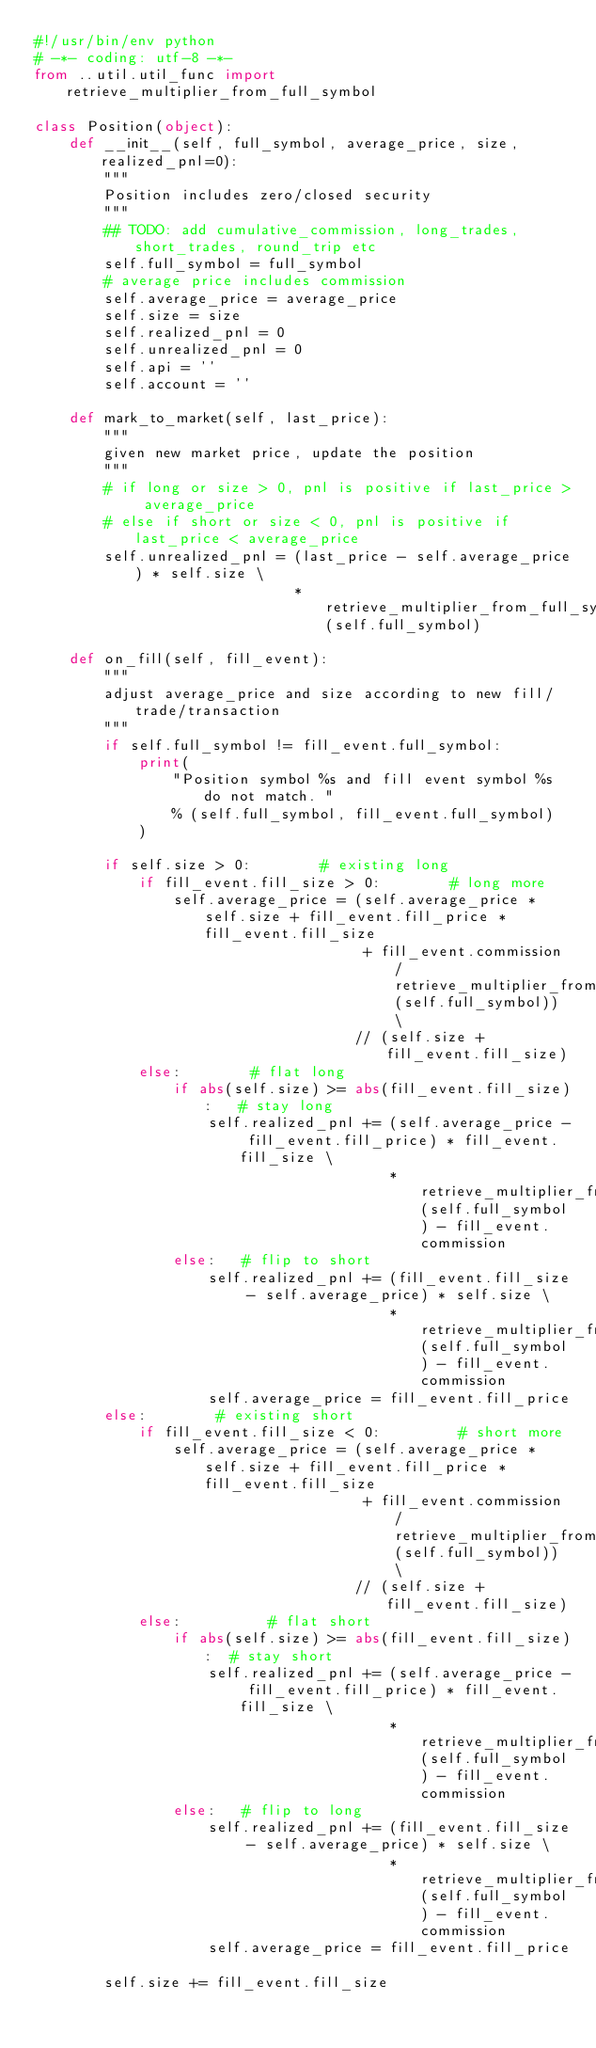Convert code to text. <code><loc_0><loc_0><loc_500><loc_500><_Python_>#!/usr/bin/env python
# -*- coding: utf-8 -*-
from ..util.util_func import retrieve_multiplier_from_full_symbol

class Position(object):
    def __init__(self, full_symbol, average_price, size, realized_pnl=0):
        """
        Position includes zero/closed security
        """
        ## TODO: add cumulative_commission, long_trades, short_trades, round_trip etc
        self.full_symbol = full_symbol
        # average price includes commission
        self.average_price = average_price
        self.size = size
        self.realized_pnl = 0
        self.unrealized_pnl = 0
        self.api = ''
        self.account = ''

    def mark_to_market(self, last_price):
        """
        given new market price, update the position
        """
        # if long or size > 0, pnl is positive if last_price > average_price
        # else if short or size < 0, pnl is positive if last_price < average_price
        self.unrealized_pnl = (last_price - self.average_price) * self.size \
                              * retrieve_multiplier_from_full_symbol(self.full_symbol)

    def on_fill(self, fill_event):
        """
        adjust average_price and size according to new fill/trade/transaction
        """
        if self.full_symbol != fill_event.full_symbol:
            print(
                "Position symbol %s and fill event symbol %s do not match. "
                % (self.full_symbol, fill_event.full_symbol)
            )

        if self.size > 0:        # existing long
            if fill_event.fill_size > 0:        # long more
                self.average_price = (self.average_price * self.size + fill_event.fill_price * fill_event.fill_size
                                      + fill_event.commission / retrieve_multiplier_from_full_symbol(self.full_symbol)) \
                                     // (self.size + fill_event.fill_size)
            else:        # flat long
                if abs(self.size) >= abs(fill_event.fill_size):   # stay long
                    self.realized_pnl += (self.average_price - fill_event.fill_price) * fill_event.fill_size \
                                         * retrieve_multiplier_from_full_symbol(self.full_symbol) - fill_event.commission
                else:   # flip to short
                    self.realized_pnl += (fill_event.fill_size - self.average_price) * self.size \
                                         * retrieve_multiplier_from_full_symbol(self.full_symbol) - fill_event.commission
                    self.average_price = fill_event.fill_price
        else:        # existing short
            if fill_event.fill_size < 0:         # short more
                self.average_price = (self.average_price * self.size + fill_event.fill_price * fill_event.fill_size
                                      + fill_event.commission / retrieve_multiplier_from_full_symbol(self.full_symbol)) \
                                     // (self.size + fill_event.fill_size)
            else:          # flat short
                if abs(self.size) >= abs(fill_event.fill_size):  # stay short
                    self.realized_pnl += (self.average_price - fill_event.fill_price) * fill_event.fill_size \
                                         * retrieve_multiplier_from_full_symbol(self.full_symbol) - fill_event.commission
                else:   # flip to long
                    self.realized_pnl += (fill_event.fill_size - self.average_price) * self.size \
                                         * retrieve_multiplier_from_full_symbol(self.full_symbol) - fill_event.commission
                    self.average_price = fill_event.fill_price

        self.size += fill_event.fill_size</code> 